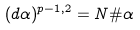Convert formula to latex. <formula><loc_0><loc_0><loc_500><loc_500>( d \alpha ) ^ { p - 1 , 2 } = N \# \alpha</formula> 